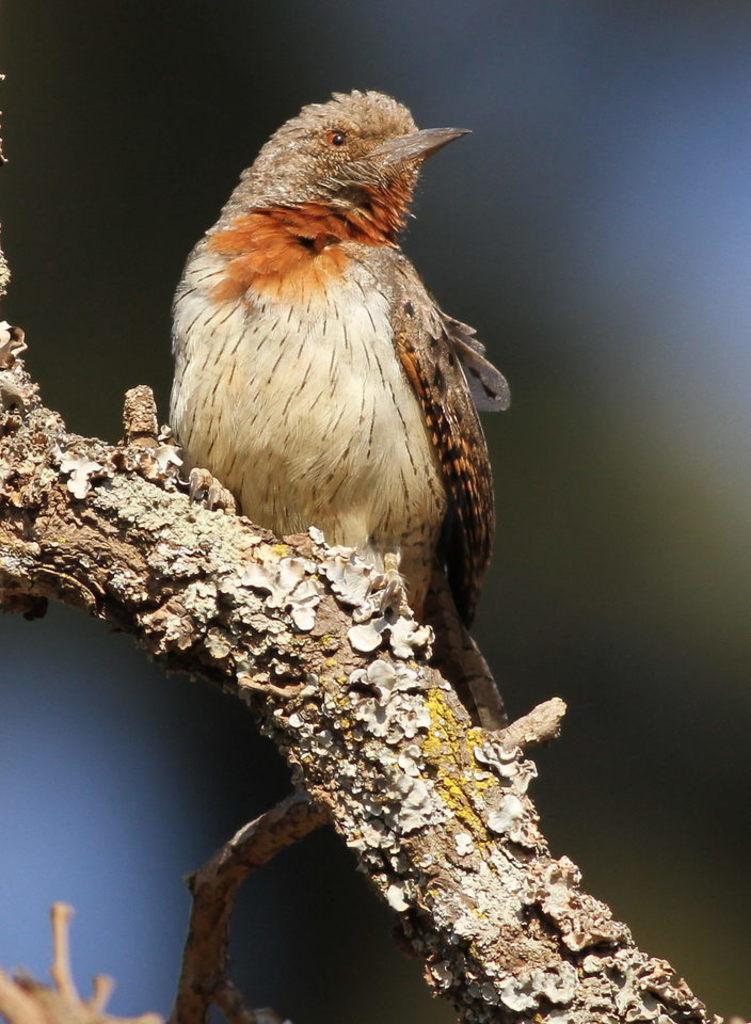Could you give a brief overview of what you see in this image? In this image we can see a bird on the branch. There is a blur background. 